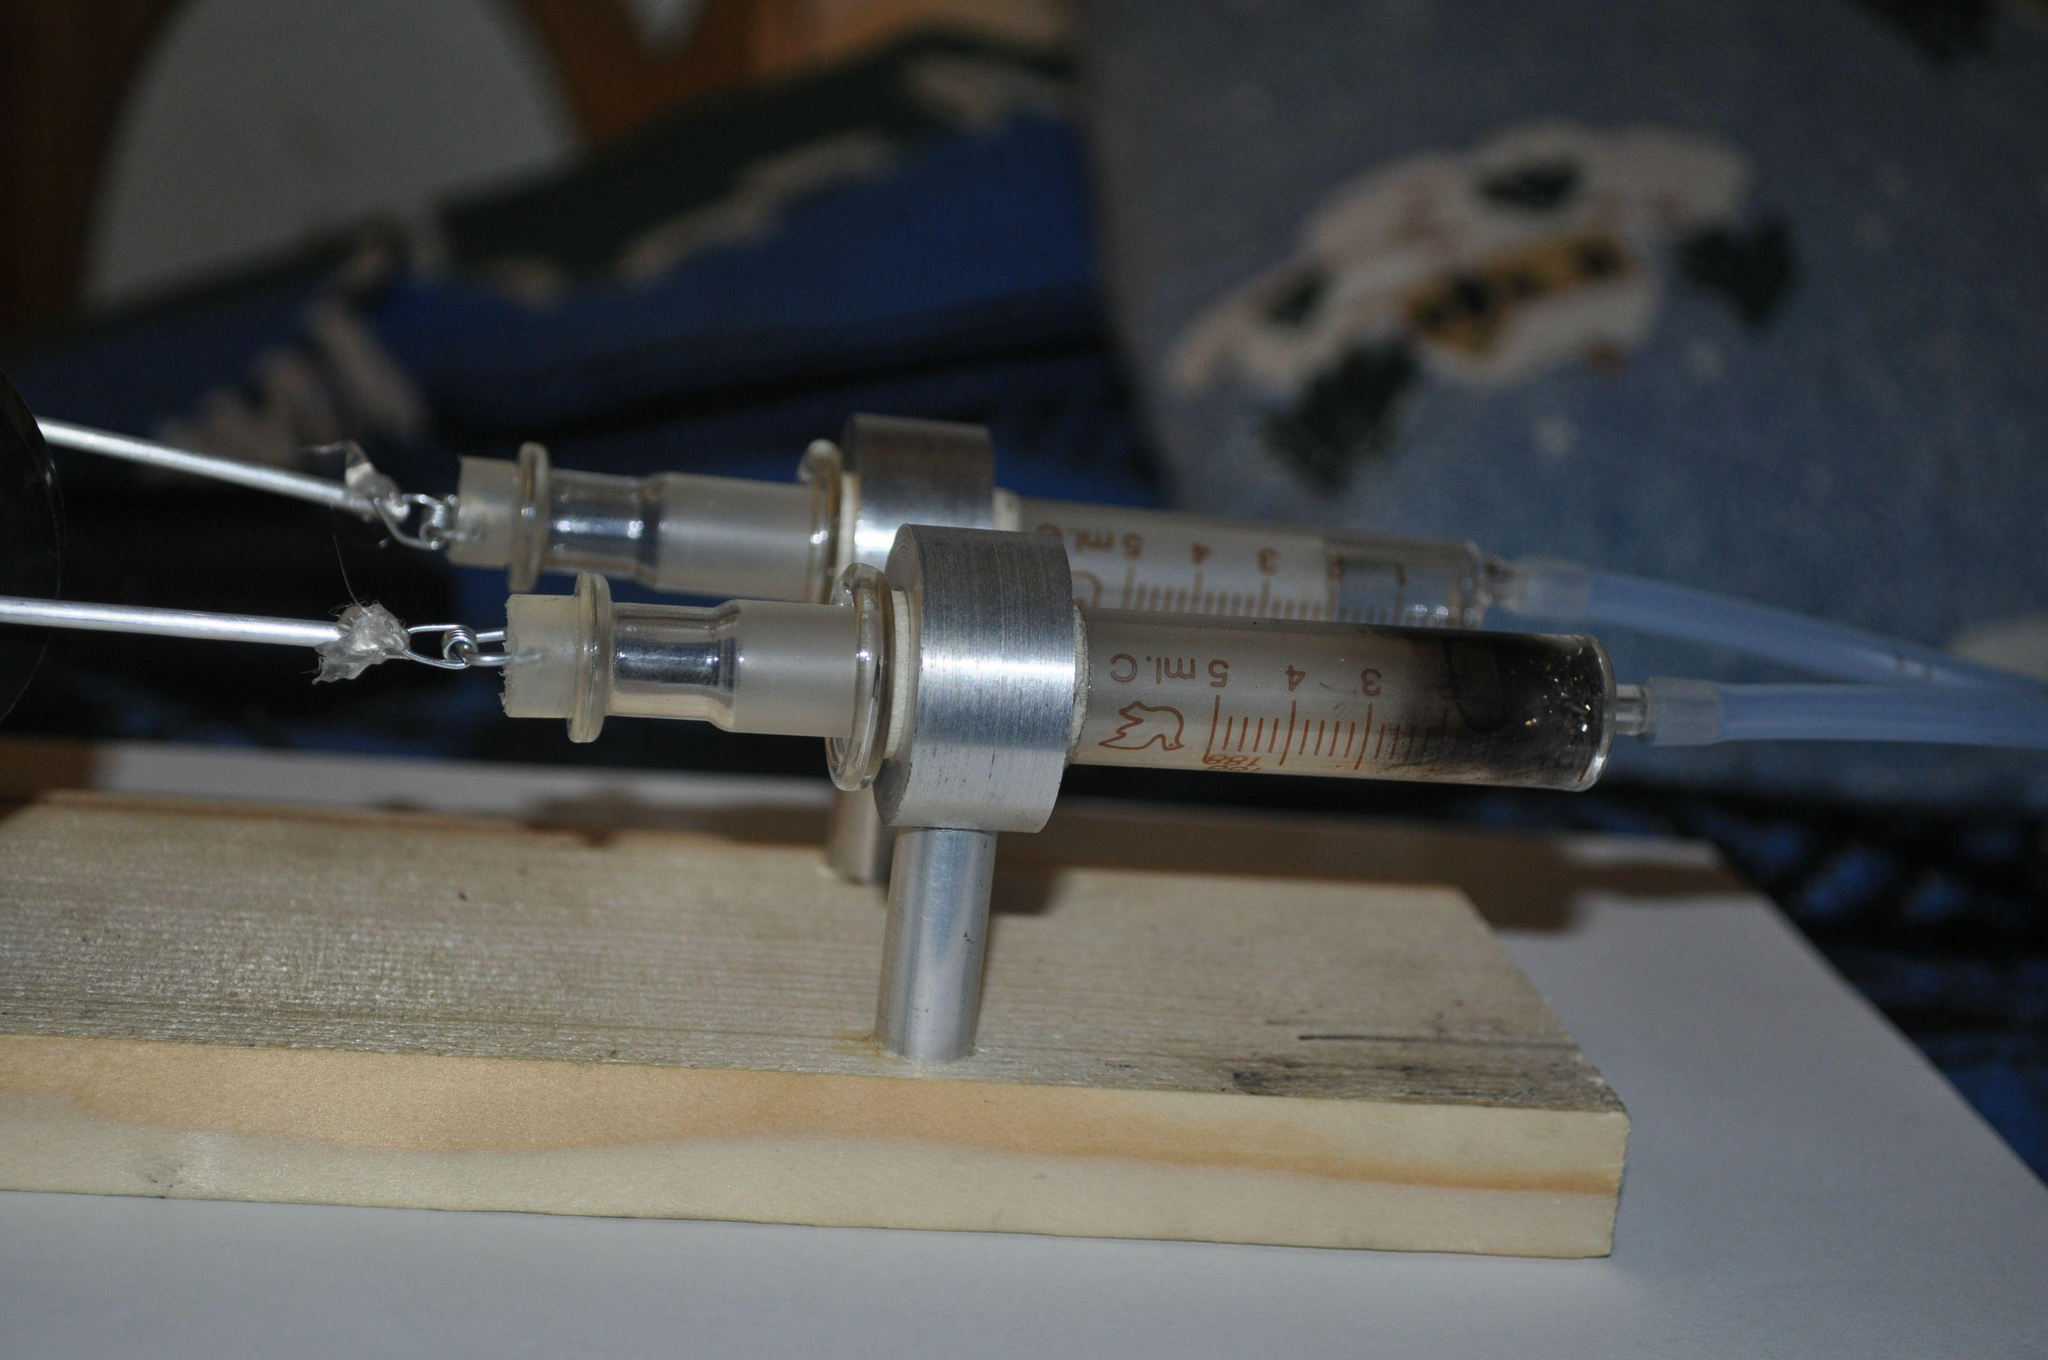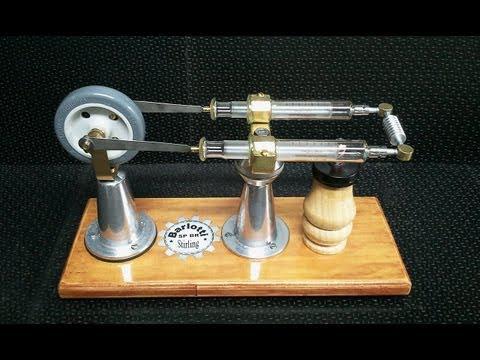The first image is the image on the left, the second image is the image on the right. Given the left and right images, does the statement "The right image shows a pair of syringes that have been used to construct some sort of mechanism with a wheel on it." hold true? Answer yes or no. Yes. The first image is the image on the left, the second image is the image on the right. Evaluate the accuracy of this statement regarding the images: "One syringe is in front of a rectangular item in one image.". Is it true? Answer yes or no. No. 